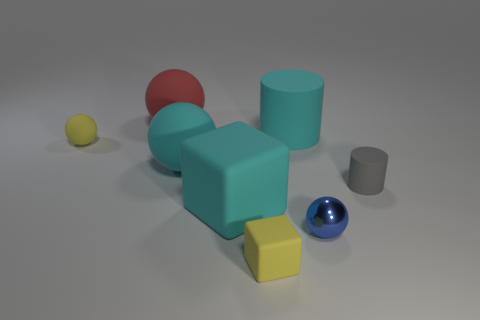Can you describe the texture and color of the objects in the image? Certainly! In the image, the objects exhibit various textures and colors. Starting with the colors, there are objects in shades of yellow, red, blue-gray, and metallic blue. The yellow objects have a non-glossy, matte finish, the red appears smooth and matte as well, while the blue-gray ones are somewhat less reflective, and there's a small metallic sphere that has a highly reflective, polished surface. Texture-wise, the objects seem smooth, with no discernible patterns or roughness visible from this angle. 